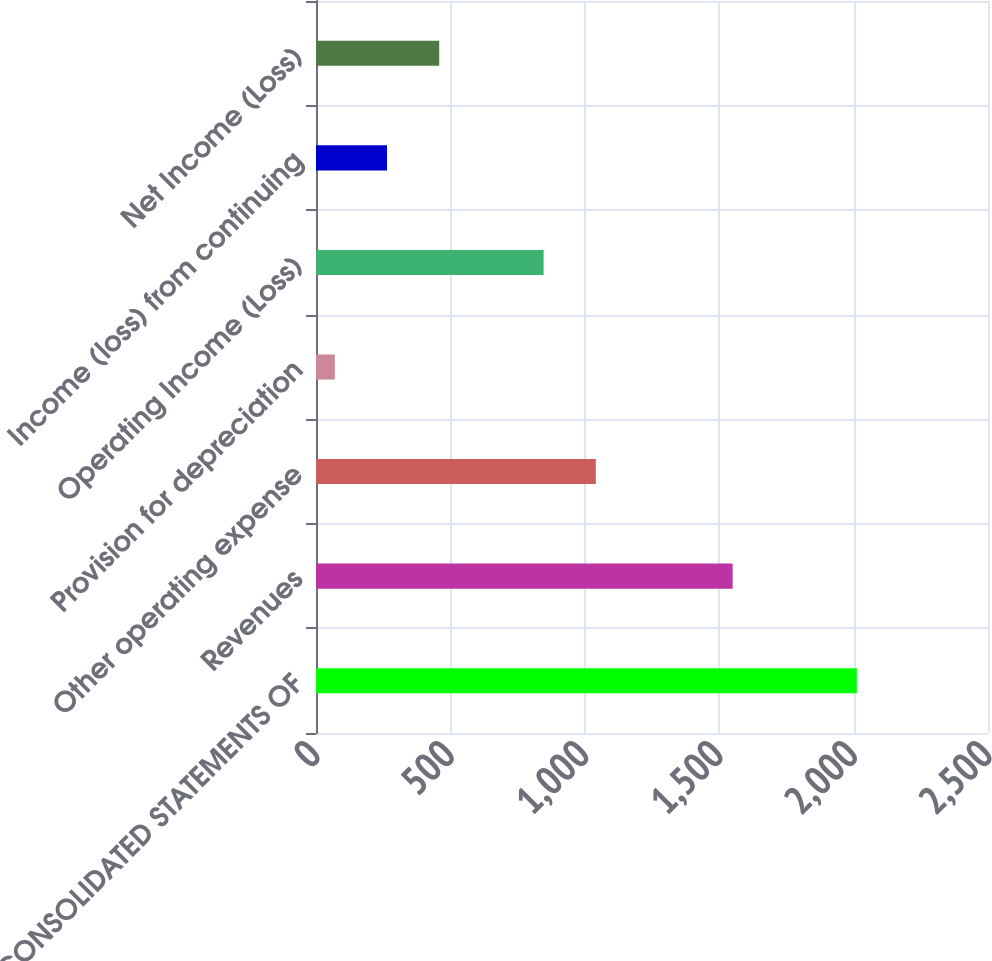Convert chart to OTSL. <chart><loc_0><loc_0><loc_500><loc_500><bar_chart><fcel>CONSOLIDATED STATEMENTS OF<fcel>Revenues<fcel>Other operating expense<fcel>Provision for depreciation<fcel>Operating Income (Loss)<fcel>Income (loss) from continuing<fcel>Net Income (Loss)<nl><fcel>2012<fcel>1550<fcel>1041<fcel>70<fcel>846.8<fcel>264.2<fcel>458.4<nl></chart> 